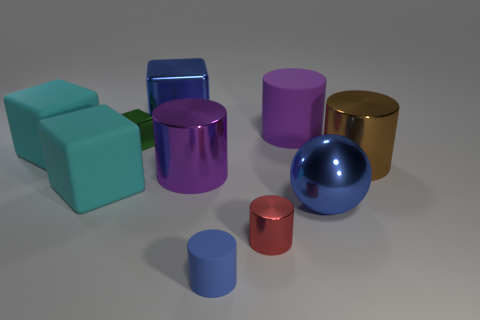Could you describe the composition of colors and shapes? Certainly! The composition exhibits a variety of geometric shapes such as cylinders, a sphere, and a cube. The colors are diverse too, including blue, red, purple, teal, and gold. This selection creates a harmonious yet dynamic assortment, with shiny and matte finishes providing contrast and visual interest. 